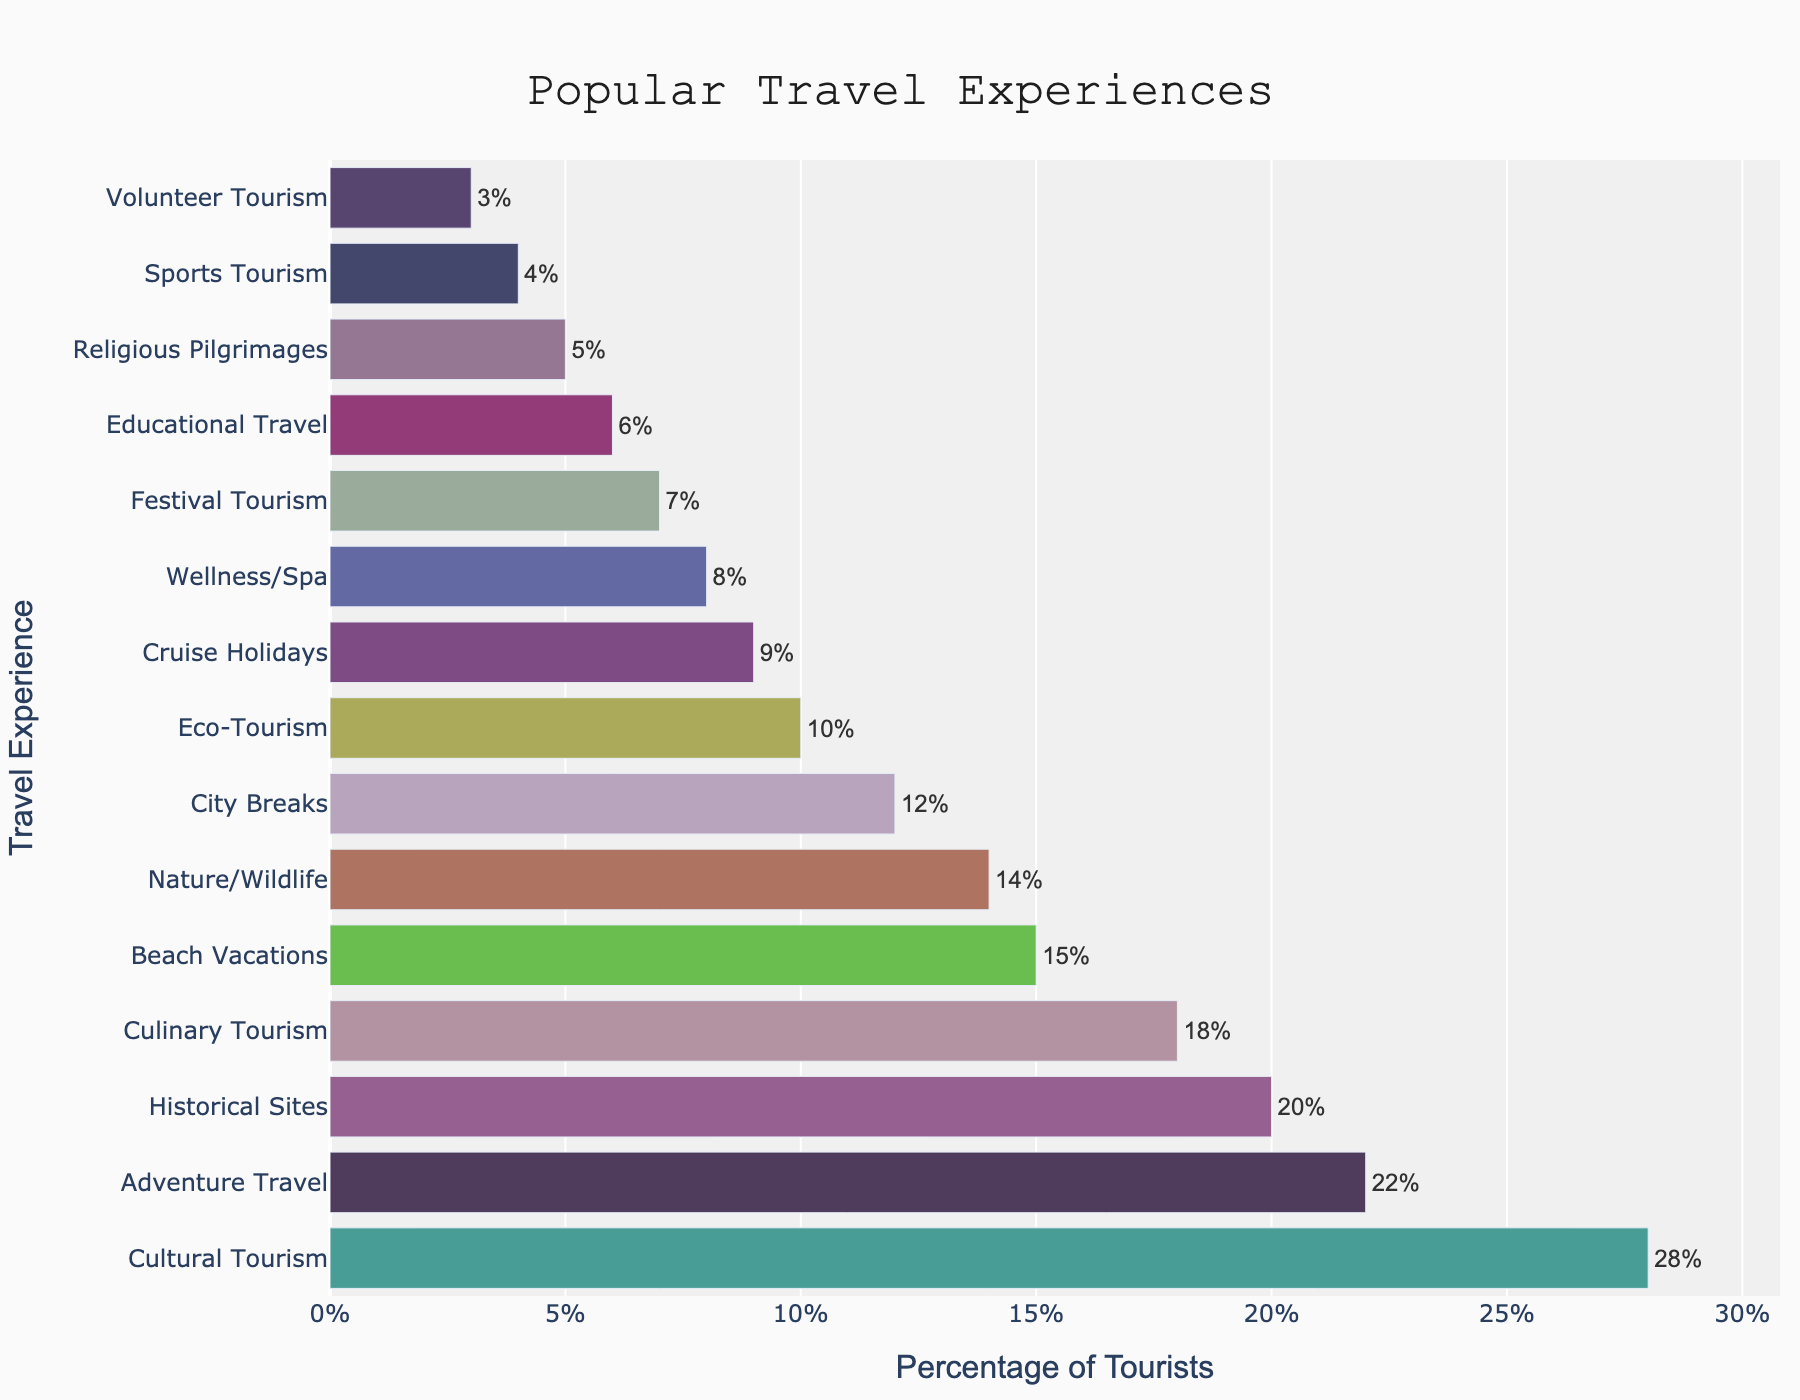Which travel experience has the highest percentage of tourists? The travel experience with the highest percentage is at the top of the bar chart and is visually the longest bar.
Answer: Cultural Tourism What is the combined percentage of tourists engaging in Cultural Tourism and Adventure Travel? The percentage for Cultural Tourism is 28%, and for Adventure Travel, it is 22%. Adding these together: 28 + 22 = 50%.
Answer: 50% How much more popular is Beach Vacations compared to Wellness/Spa experiences? Beach Vacations have a percentage of 15%, whereas Wellness/Spa experiences have 8%. Subtracting these two: 15 - 8 = 7%.
Answer: 7% Rank the top three travel experiences by percentage. The top three percentages are 28% (Cultural Tourism), 22% (Adventure Travel), and 20% (Historical Sites).
Answer: Cultural Tourism, Adventure Travel, Historical Sites What is the median percentage value of all the travel experiences? First, list all percentages in ascending order: 3, 4, 5, 6, 7, 8, 9, 10, 12, 14, 15, 18, 20, 22, 28. The median value is the middle of this ordered list, the 8th value, which is 10%.
Answer: 10% Which travel experience is less popular: City Breaks or Nature/Wildlife? From the bar chart, City Breaks is at 12% and Nature/Wildlife is at 14%. Since 12% is less than 14%, City Breaks is less popular.
Answer: City Breaks How does the percentage of tourists engaging in Culinary Tourism compare to those going on Cruise Holidays? Culinary Tourism has a percentage of 18%, while Cruise Holidays have 9%. 18% is twice as large as 9%.
Answer: Culinary Tourism is twice as popular as Cruise Holidays What travel experiences make up the lower quartile of the dataset in terms of percentage? In the ascending list (3, 4, 5, 6, 7, 8, 9, 10, 12, 14, 15, 18, 20, 22, 28), the lower quartile is the bottom 25%. There are 15 values, so the first 4 represent the lower quartile: 3, 4, 5, 6. The corresponding experiences are: Volunteer Tourism (3%), Sports Tourism (4%), Religious Pilgrimages (5%), and Educational Travel (6%).
Answer: Volunteer Tourism, Sports Tourism, Religious Pilgrimages, Educational Travel 